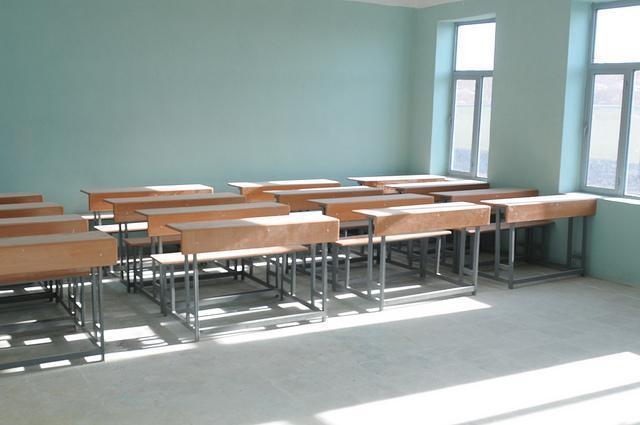How many benches can be seen?
Give a very brief answer. 3. 